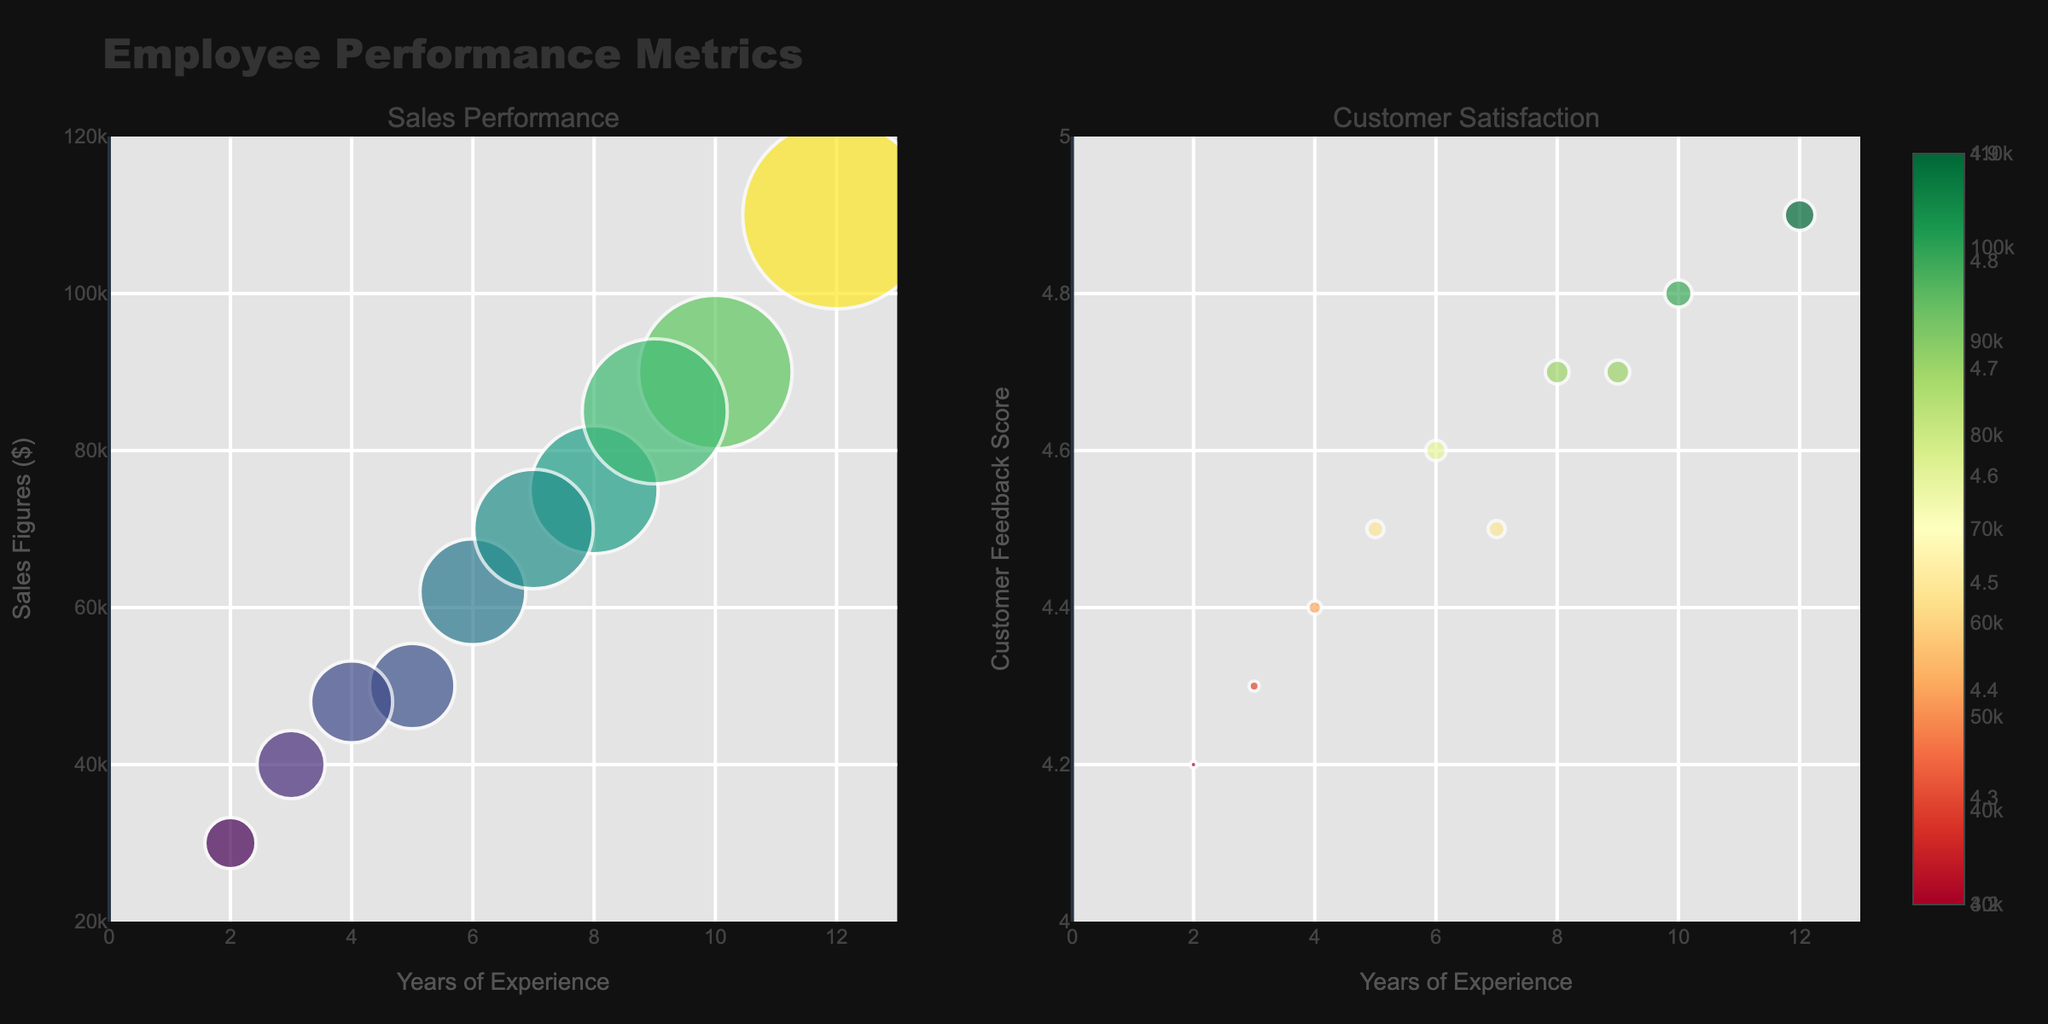what is the title of the figure? The title of the figure is displayed at the top of the plot in larger font compared to other text elements. In this case, the title is 'Employee Performance Metrics'.
Answer: Employee Performance Metrics how many subplots are there in the figure? The figure contains two subplots, which can be observed from the layout where the plot is divided into two parts side by side, each with its own title above.
Answer: 2 what is the x-axis range for the subplot on the left? The x-axis range for the subplot on the left is indicated at the bottom of the axis, showing the minimum and maximum values. Here, it ranges from 0 to 13.
Answer: 0 to 13 what is the relationship between years of experience and sales figures for George Miller? To find George Miller, find the dot labeled with his name and look at its position on both the x and y-axes. George Miller has 12 years of experience and sales figures of $110,000.
Answer: 12 years, $110,000 which employee has the highest customer feedback score and what is that score? The highest customer feedback score can be identified by finding the highest point on the y-axis of the right subplot. By checking the hover text, George Miller has the highest score of 4.9.
Answer: George Miller, 4.9 compare the sales figures between John Doe and Sarah Wilson. Who has higher sales and by how much? Locate John Doe and Sarah Wilson's points on the left subplot. John Doe's sales figures are $50,000, and Sarah Wilson's are $48,000. The difference is $2,000 in favor of John Doe.
Answer: John Doe, $2,000 which employee has the minimum years of experience, and what are their sales figures and customer feedback score? Identify the point with the lowest x-axis value (years of experience) on both subplots. Michael Johnson has the minimum years of experience (2), with sales figures of $30,000 and a customer feedback score of 4.2.
Answer: Michael Johnson, $30,000, 4.2 what is the average customer feedback score of employees with more than 7 years of experience? Find all employees with more than 7 years of experience. They are Jane Smith, Emily Davis, George Miller, and Patricia Taylor with scores of 4.7, 4.8, 4.9, and 4.7. Sum these scores (4.7+4.8+4.9+4.7=19.1) and divide by the number of employees (4). The average score is 19.1 / 4 = 4.775.
Answer: 4.775 is there a trend between years of experience and sales figures in the subplot on the left? Examine the distribution of points in the left subplot. Generally, points with more years of experience tend to have higher sales figures, indicating a positive relationship.
Answer: Yes, there is a positive trend which employee's sales figures are closest to the median sales figures of all employees? Arrange the sales figures in order: $30,000, $40,000, $48,000, $50,000, $62,000, $70,000, $75,000, $85,000, $90,000, $110,000. The median of these is the average of the 5th and 6th values: ($62,000 + $70,000)/2 = $66,000. Linda Brown's sales figures at $62,000 are closest to the median.
Answer: Linda Brown, $62,000 